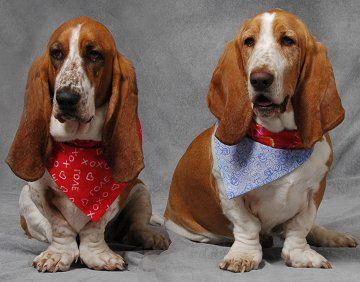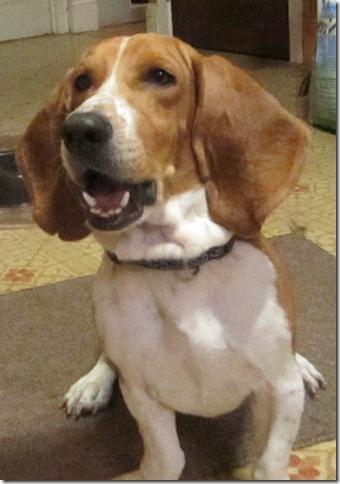The first image is the image on the left, the second image is the image on the right. Assess this claim about the two images: "There are three dogs that are not running.". Correct or not? Answer yes or no. Yes. The first image is the image on the left, the second image is the image on the right. For the images displayed, is the sentence "There is one hound in the left image and two hounds in the right image." factually correct? Answer yes or no. No. 